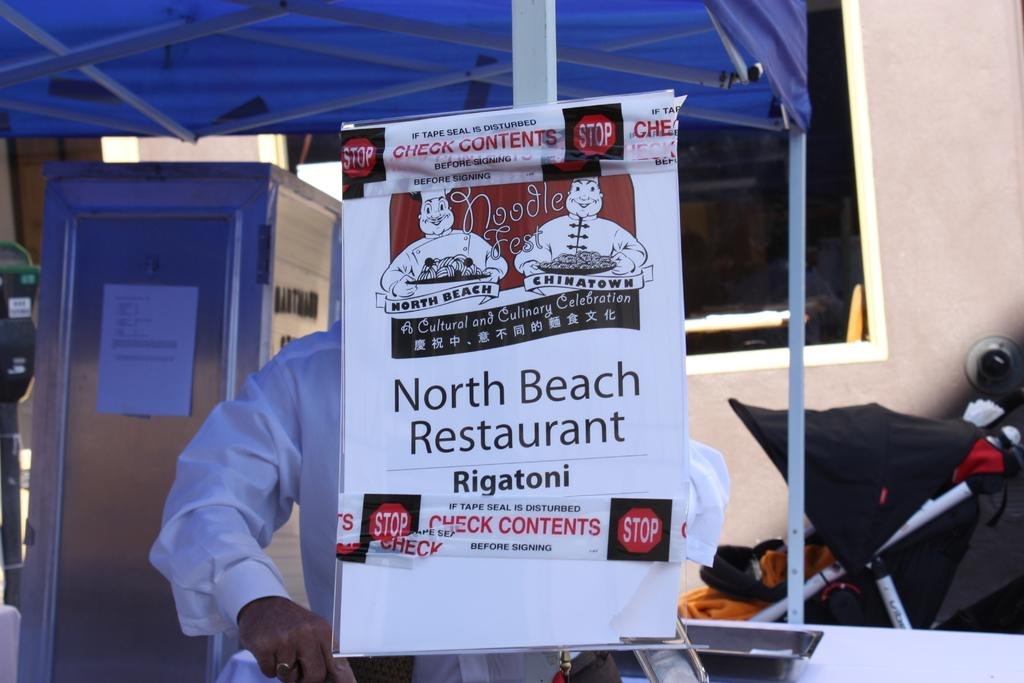What is present in the image that is used for displaying information or messages? There is a banner in the image. Can you describe the person in the background of the image? Unfortunately, the facts provided do not give any details about the person in the background. What is visible through the window in the background of the image? The window has a tint in white color, and there are objects visible in the background. What color is the tint on the window? The tint on the window is white. What type of knot is the robin using to secure the banner in the image? There is no robin or knot present in the image. The banner is not secured with a knot, but rather displayed for information or messages. 